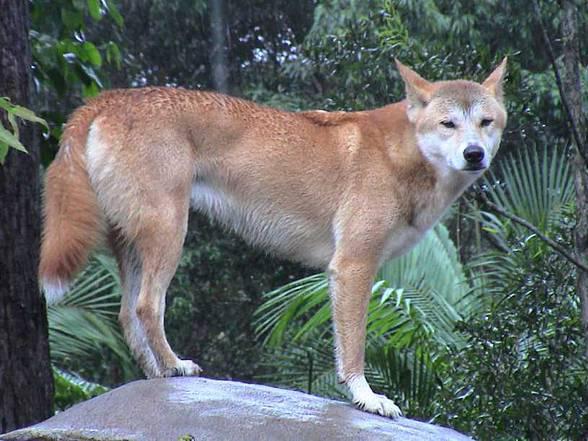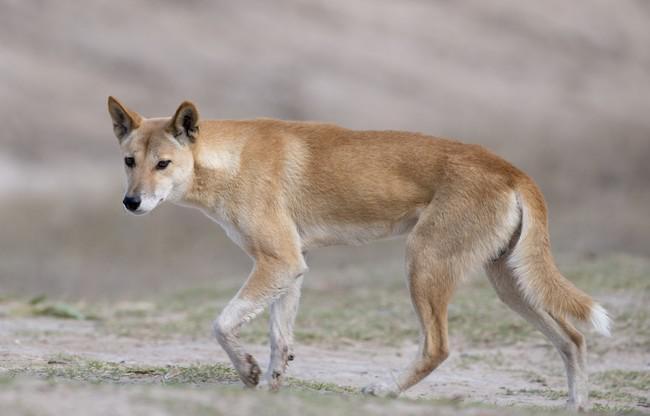The first image is the image on the left, the second image is the image on the right. Analyze the images presented: Is the assertion "The wild dog in the image on the right is lying down outside." valid? Answer yes or no. No. The first image is the image on the left, the second image is the image on the right. Analyze the images presented: Is the assertion "There are at most two dingoes." valid? Answer yes or no. Yes. 